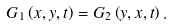<formula> <loc_0><loc_0><loc_500><loc_500>G _ { 1 } \left ( x , y , t \right ) = G _ { 2 } \left ( y , x , t \right ) .</formula> 